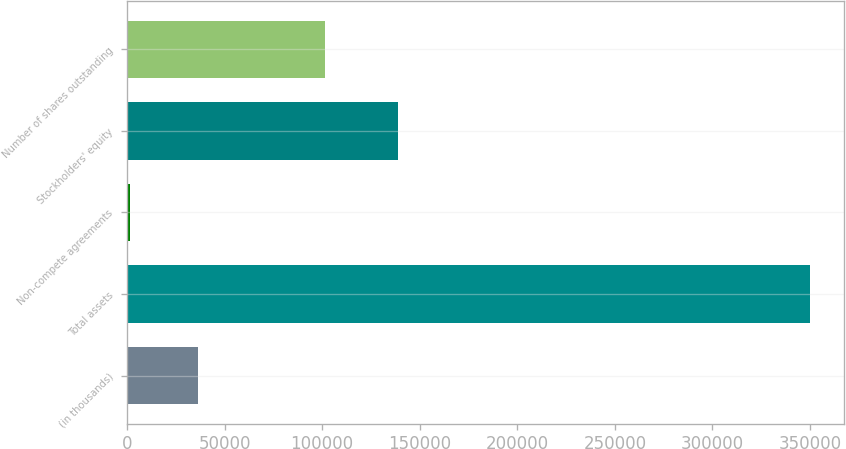Convert chart. <chart><loc_0><loc_0><loc_500><loc_500><bar_chart><fcel>(in thousands)<fcel>Total assets<fcel>Non-compete agreements<fcel>Stockholders' equity<fcel>Number of shares outstanding<nl><fcel>36551<fcel>349904<fcel>1734<fcel>138774<fcel>101603<nl></chart> 